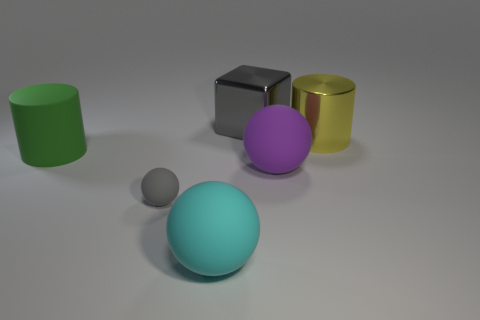What number of green objects are either big metal cylinders or cylinders?
Provide a succinct answer. 1. There is a matte ball on the right side of the large ball left of the block; what is its color?
Provide a succinct answer. Purple. What material is the large thing that is the same color as the small matte thing?
Ensure brevity in your answer.  Metal. There is a large cylinder that is on the right side of the large gray metal cube; what color is it?
Your answer should be very brief. Yellow. There is a gray metallic object on the right side of the green matte cylinder; does it have the same size as the gray matte ball?
Your response must be concise. No. There is a metallic thing that is the same color as the tiny rubber object; what size is it?
Ensure brevity in your answer.  Large. Are there any gray matte spheres of the same size as the green cylinder?
Your answer should be very brief. No. There is a large cylinder that is to the right of the green object; is its color the same as the large matte thing in front of the gray matte ball?
Your answer should be compact. No. Are there any small metallic cylinders that have the same color as the tiny rubber thing?
Make the answer very short. No. How many other things are there of the same shape as the big purple thing?
Keep it short and to the point. 2. 